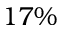<formula> <loc_0><loc_0><loc_500><loc_500>1 7 \%</formula> 